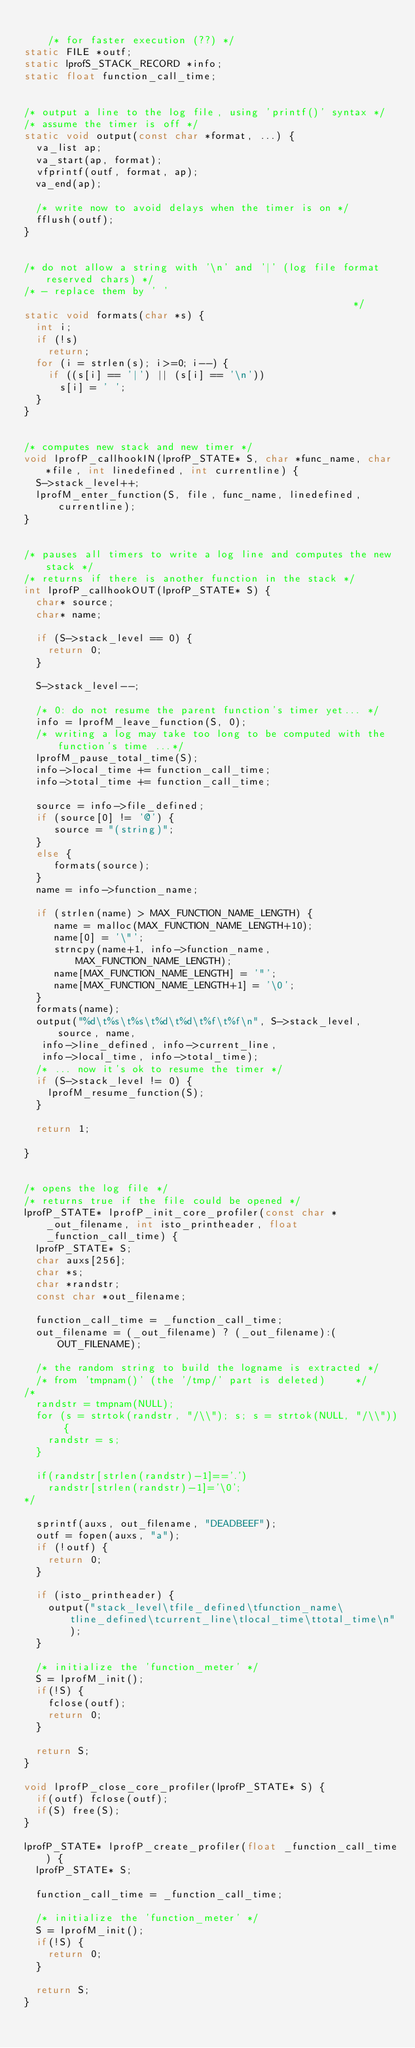Convert code to text. <code><loc_0><loc_0><loc_500><loc_500><_C_>
    /* for faster execution (??) */
static FILE *outf;
static lprofS_STACK_RECORD *info;
static float function_call_time;


/* output a line to the log file, using 'printf()' syntax */
/* assume the timer is off */
static void output(const char *format, ...) {
  va_list ap;
  va_start(ap, format);
  vfprintf(outf, format, ap);
  va_end(ap);

  /* write now to avoid delays when the timer is on */
  fflush(outf);
}


/* do not allow a string with '\n' and '|' (log file format reserved chars) */
/* - replace them by ' '                                                    */
static void formats(char *s) {
  int i;
  if (!s)
    return;
  for (i = strlen(s); i>=0; i--) {
    if ((s[i] == '|') || (s[i] == '\n'))
      s[i] = ' ';
  }
}


/* computes new stack and new timer */
void lprofP_callhookIN(lprofP_STATE* S, char *func_name, char *file, int linedefined, int currentline) {	
  S->stack_level++;
  lprofM_enter_function(S, file, func_name, linedefined, currentline);
}


/* pauses all timers to write a log line and computes the new stack */
/* returns if there is another function in the stack */
int lprofP_callhookOUT(lprofP_STATE* S) {
	char* source;
	char* name;

  if (S->stack_level == 0) {
    return 0;
  }

  S->stack_level--;

  /* 0: do not resume the parent function's timer yet... */
  info = lprofM_leave_function(S, 0);
  /* writing a log may take too long to be computed with the function's time ...*/
  lprofM_pause_total_time(S);
  info->local_time += function_call_time;
  info->total_time += function_call_time;
  
  source = info->file_defined;
  if (source[0] != '@') {
     source = "(string)";
  }
  else {
     formats(source);
  }
  name = info->function_name;
  
  if (strlen(name) > MAX_FUNCTION_NAME_LENGTH) {
     name = malloc(MAX_FUNCTION_NAME_LENGTH+10);
     name[0] = '\"';
     strncpy(name+1, info->function_name, MAX_FUNCTION_NAME_LENGTH);
     name[MAX_FUNCTION_NAME_LENGTH] = '"';
     name[MAX_FUNCTION_NAME_LENGTH+1] = '\0';
  }
  formats(name);
  output("%d\t%s\t%s\t%d\t%d\t%f\t%f\n", S->stack_level, source, name, 
	 info->line_defined, info->current_line,
	 info->local_time, info->total_time);
  /* ... now it's ok to resume the timer */
  if (S->stack_level != 0) {
    lprofM_resume_function(S);
  }

  return 1;

}


/* opens the log file */
/* returns true if the file could be opened */
lprofP_STATE* lprofP_init_core_profiler(const char *_out_filename, int isto_printheader, float _function_call_time) {
  lprofP_STATE* S;
  char auxs[256];
  char *s;
  char *randstr;
  const char *out_filename;

  function_call_time = _function_call_time;
  out_filename = (_out_filename) ? (_out_filename):(OUT_FILENAME);
        
  /* the random string to build the logname is extracted */
  /* from 'tmpnam()' (the '/tmp/' part is deleted)     */
/*
  randstr = tmpnam(NULL);
  for (s = strtok(randstr, "/\\"); s; s = strtok(NULL, "/\\")) {
    randstr = s;
  }

  if(randstr[strlen(randstr)-1]=='.')
    randstr[strlen(randstr)-1]='\0';
*/

  sprintf(auxs, out_filename, "DEADBEEF");
  outf = fopen(auxs, "a");
  if (!outf) {
    return 0;
  }

  if (isto_printheader) {
    output("stack_level\tfile_defined\tfunction_name\tline_defined\tcurrent_line\tlocal_time\ttotal_time\n");
  }

  /* initialize the 'function_meter' */
  S = lprofM_init();
  if(!S) {
    fclose(outf);
    return 0;
  }
    
  return S;
}

void lprofP_close_core_profiler(lprofP_STATE* S) {
  if(outf) fclose(outf);
  if(S) free(S);
}

lprofP_STATE* lprofP_create_profiler(float _function_call_time) {
  lprofP_STATE* S;

  function_call_time = _function_call_time;

  /* initialize the 'function_meter' */
  S = lprofM_init();
  if(!S) {
    return 0;
  }
    
  return S;
}

</code> 